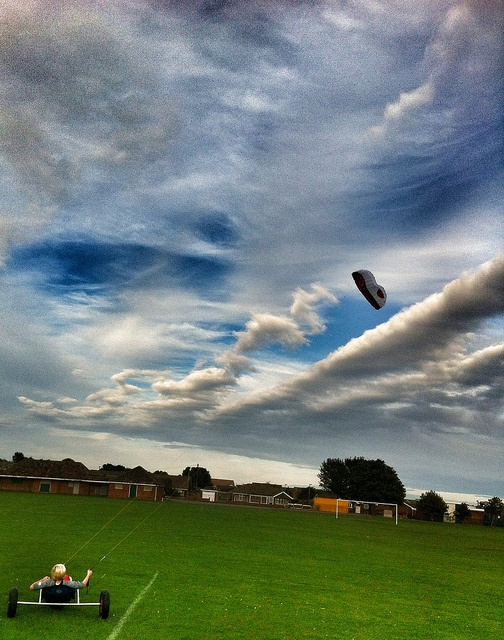Describe the objects in this image and their specific colors. I can see people in lightgray, black, gray, and olive tones and kite in lightgray, black, gray, and darkgray tones in this image. 